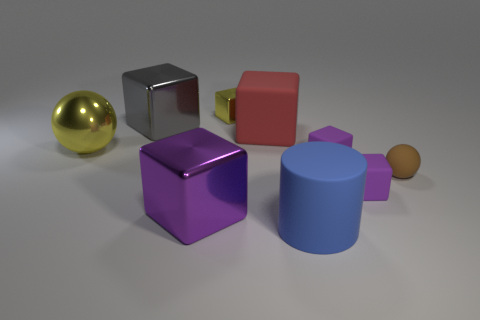There is a block that is on the right side of the yellow block and in front of the small rubber sphere; what is its color? The block situated on the right side of the yellow block and in front of the small rubber sphere has a distinct purple color, giving it a vibrant and standout appearance among the other objects. 